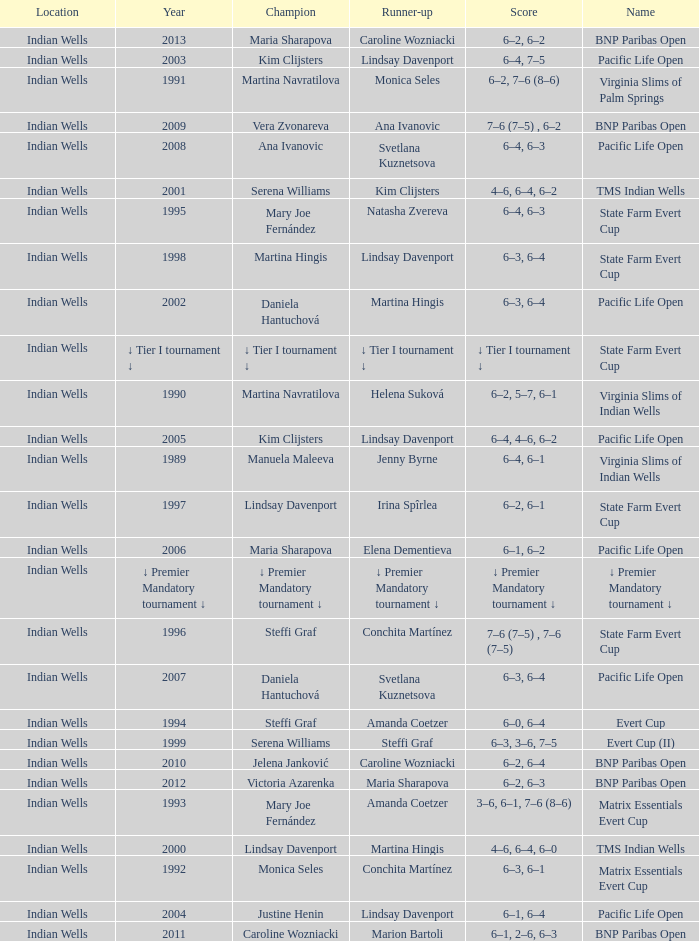Who was runner-up in the 2006 Pacific Life Open? Elena Dementieva. 